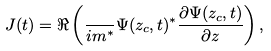<formula> <loc_0><loc_0><loc_500><loc_500>J ( t ) = \Re \left ( \frac { } { i m ^ { * } } \Psi ( z _ { c } , t ) ^ { * } \frac { \partial \Psi ( z _ { c } , t ) } { \partial z } \right ) ,</formula> 